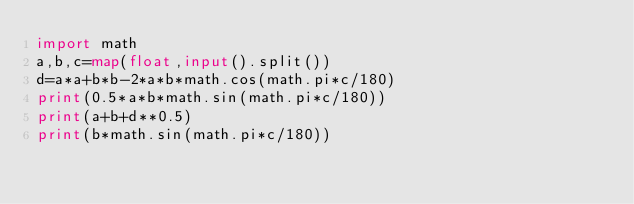Convert code to text. <code><loc_0><loc_0><loc_500><loc_500><_Python_>import math 
a,b,c=map(float,input().split())
d=a*a+b*b-2*a*b*math.cos(math.pi*c/180)
print(0.5*a*b*math.sin(math.pi*c/180))
print(a+b+d**0.5)
print(b*math.sin(math.pi*c/180))
</code> 